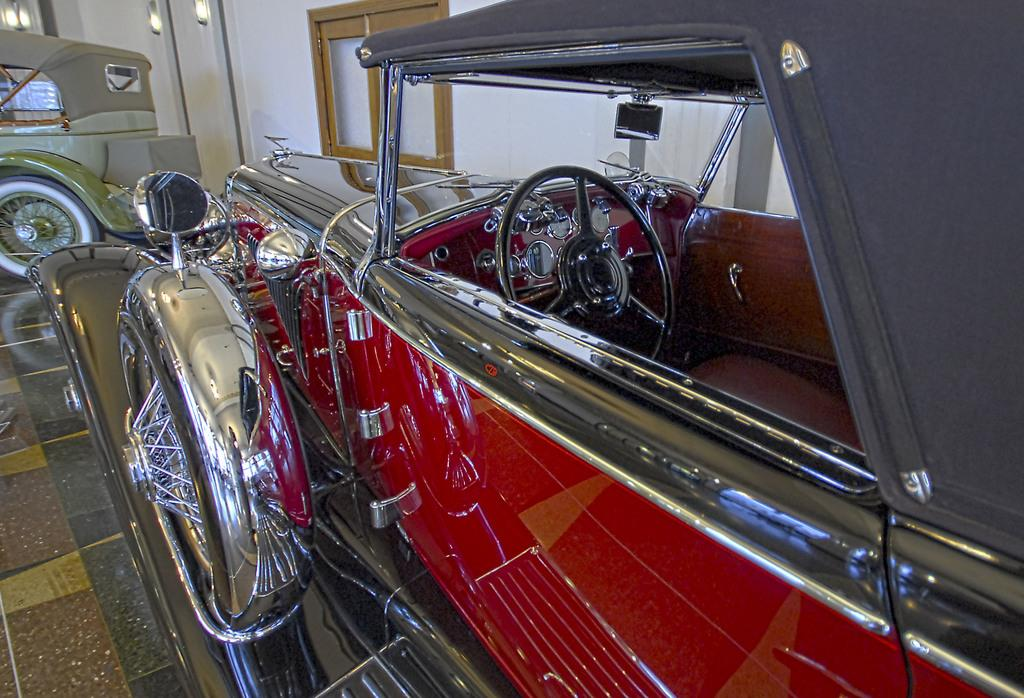What type of vehicles are in the image? There are vintage cars in the image. Where are the vintage cars located? The vintage cars are parked on the floor. What can be seen behind the vintage cars? There is a wall visible in the image. What feature is present in the center of the wall? There is a glass window in the center of the wall. What decorative elements are present at the top of the wall? There are lambs at the top of the wall. What type of plastic material is covering the vintage cars in the image? There is no plastic material covering the vintage cars in the image; they are parked on the floor without any covering. 